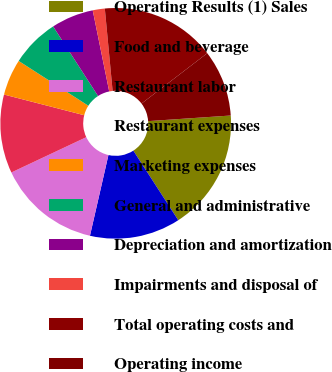Convert chart. <chart><loc_0><loc_0><loc_500><loc_500><pie_chart><fcel>Operating Results (1) Sales<fcel>Food and beverage<fcel>Restaurant labor<fcel>Restaurant expenses<fcel>Marketing expenses<fcel>General and administrative<fcel>Depreciation and amortization<fcel>Impairments and disposal of<fcel>Total operating costs and<fcel>Operating income<nl><fcel>16.95%<fcel>12.71%<fcel>14.41%<fcel>11.02%<fcel>5.08%<fcel>6.78%<fcel>5.93%<fcel>1.69%<fcel>16.1%<fcel>9.32%<nl></chart> 